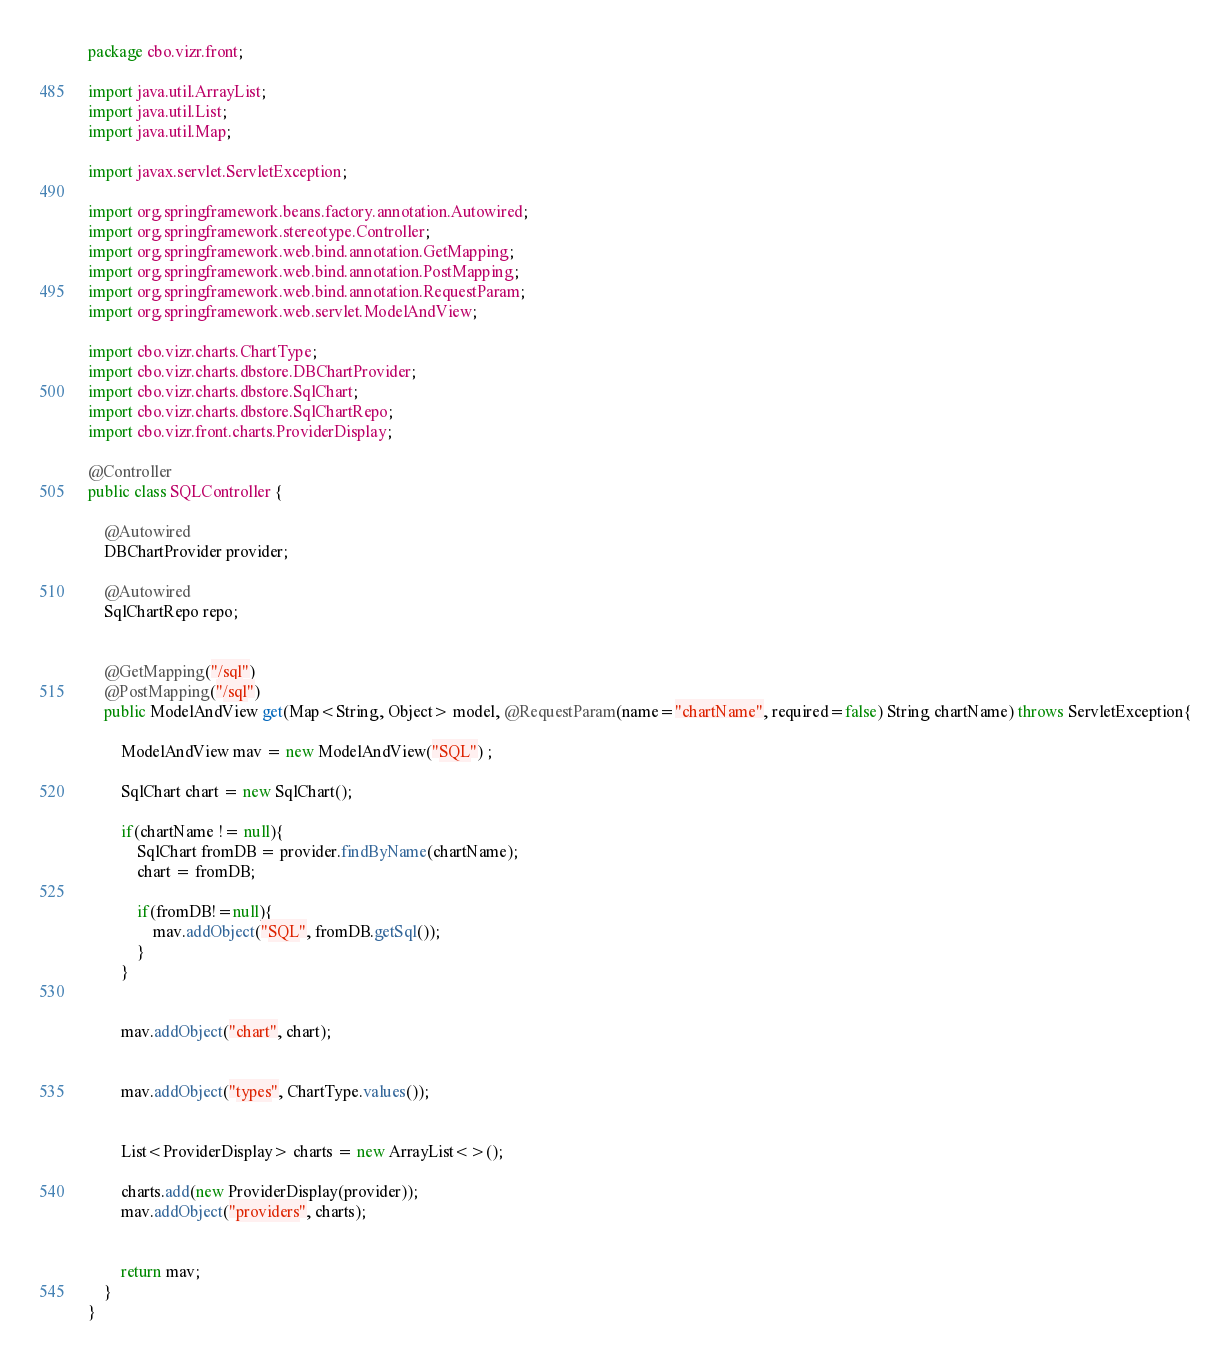<code> <loc_0><loc_0><loc_500><loc_500><_Java_>package cbo.vizr.front;

import java.util.ArrayList;
import java.util.List;
import java.util.Map;

import javax.servlet.ServletException;

import org.springframework.beans.factory.annotation.Autowired;
import org.springframework.stereotype.Controller;
import org.springframework.web.bind.annotation.GetMapping;
import org.springframework.web.bind.annotation.PostMapping;
import org.springframework.web.bind.annotation.RequestParam;
import org.springframework.web.servlet.ModelAndView;

import cbo.vizr.charts.ChartType;
import cbo.vizr.charts.dbstore.DBChartProvider;
import cbo.vizr.charts.dbstore.SqlChart;
import cbo.vizr.charts.dbstore.SqlChartRepo;
import cbo.vizr.front.charts.ProviderDisplay;

@Controller
public class SQLController {

	@Autowired
	DBChartProvider provider;
	
	@Autowired
	SqlChartRepo repo;

	
	@GetMapping("/sql")
	@PostMapping("/sql")
	public ModelAndView get(Map<String, Object> model, @RequestParam(name="chartName", required=false) String chartName) throws ServletException{

		ModelAndView mav = new ModelAndView("SQL") ;

		SqlChart chart = new SqlChart();
		
		if(chartName != null){
			SqlChart fromDB = provider.findByName(chartName);
			chart = fromDB;
			
			if(fromDB!=null){
				mav.addObject("SQL", fromDB.getSql());
			}
		}
		
		
		mav.addObject("chart", chart);
		
		
		mav.addObject("types", ChartType.values());
		
		
		List<ProviderDisplay> charts = new ArrayList<>();
		
		charts.add(new ProviderDisplay(provider));
		mav.addObject("providers", charts);
		

		return mav;
	}
}
</code> 